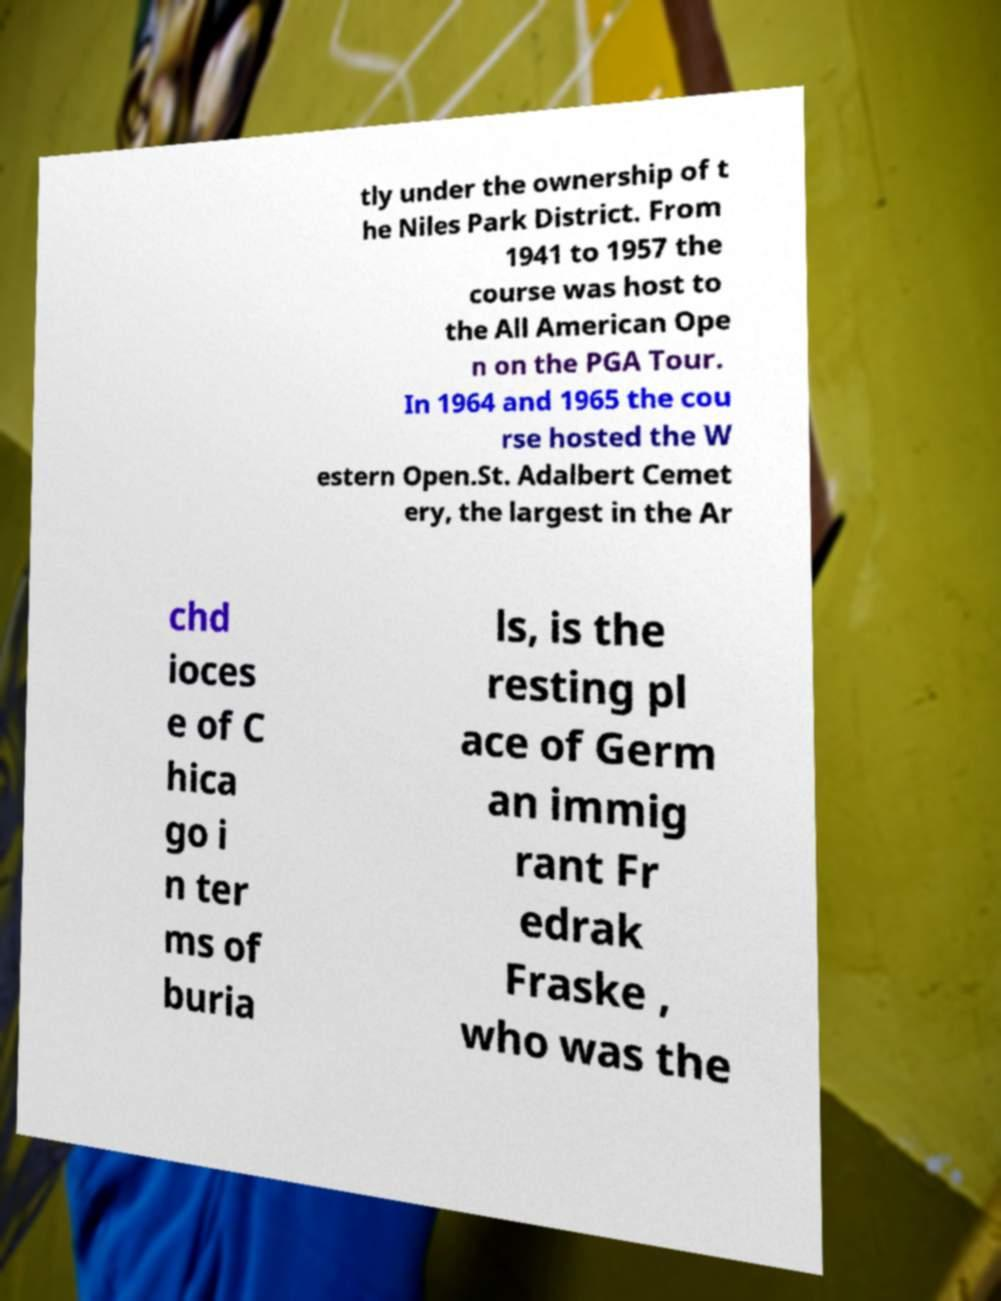For documentation purposes, I need the text within this image transcribed. Could you provide that? tly under the ownership of t he Niles Park District. From 1941 to 1957 the course was host to the All American Ope n on the PGA Tour. In 1964 and 1965 the cou rse hosted the W estern Open.St. Adalbert Cemet ery, the largest in the Ar chd ioces e of C hica go i n ter ms of buria ls, is the resting pl ace of Germ an immig rant Fr edrak Fraske , who was the 